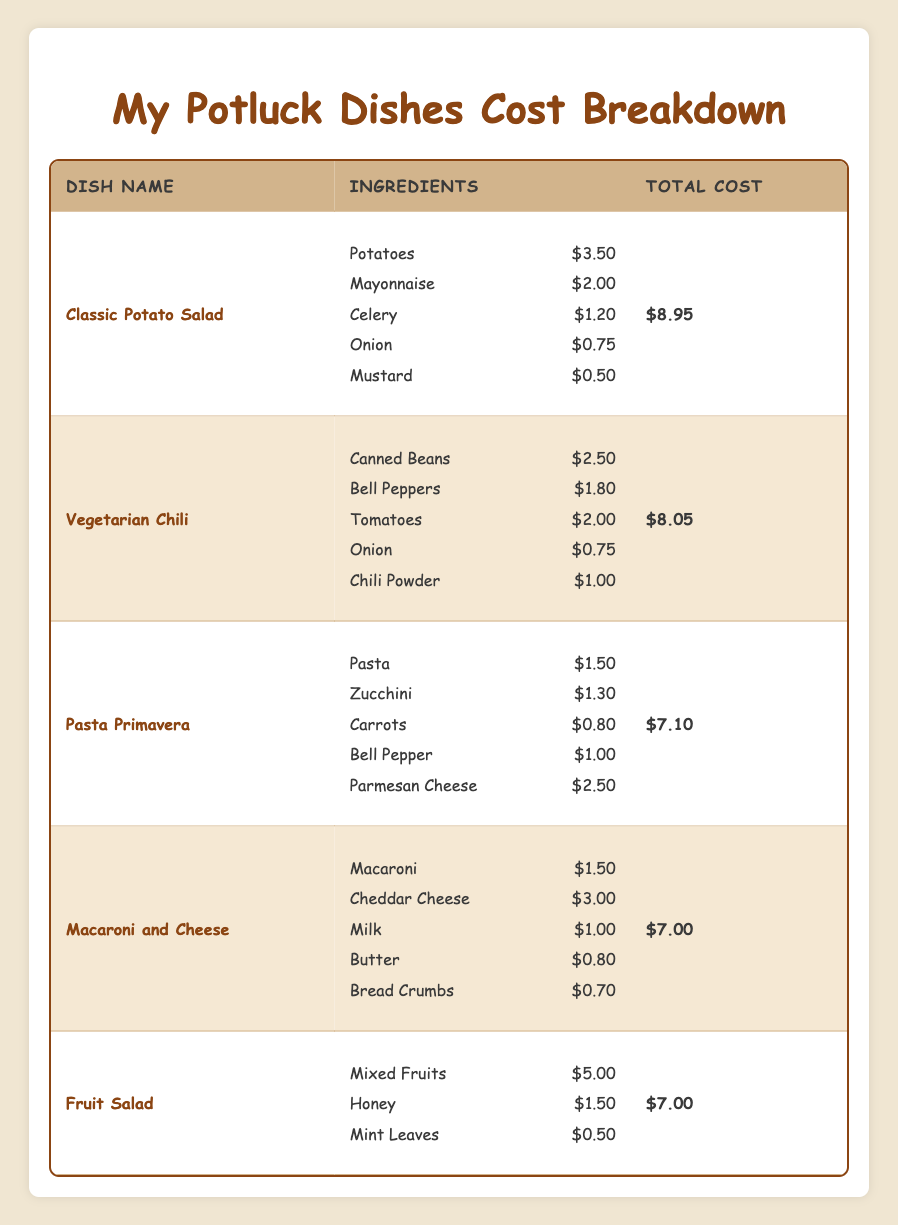What is the total cost of the Classic Potato Salad? The total cost for the Classic Potato Salad is listed directly in the table as $8.95.
Answer: $8.95 Which ingredient in the Vegetarian Chili costs the most? Looking at the ingredient list for Vegetarian Chili, the highest cost is for Tomatoes at $2.00.
Answer: Tomatoes How much does the combined cost of all ingredients in Pasta Primavera amount to? The summation of all ingredients in Pasta Primavera is calculated as follows: $1.50 (Pasta) + $1.30 (Zucchini) + $0.80 (Carrots) + $1.00 (Bell Pepper) + $2.50 (Parmesan Cheese) = $7.10
Answer: $7.10 Is the total cost of Macaroni and Cheese less than that of Vegetarian Chili? The total cost of Macaroni and Cheese is $7.00, and Vegetarian Chili is $8.05. Since $7.00 is less than $8.05, the statement is true.
Answer: Yes How much cheaper is the Classic Potato Salad compared to the Vegetarian Chili? The difference in cost between Classic Potato Salad ($8.95) and Vegetarian Chili ($8.05) is calculated as $8.95 - $8.05 = $0.90.
Answer: $0.90 What is the average cost of ingredients in Fruit Salad? The Fruit Salad has 3 ingredients: Mixed Fruits ($5.00), Honey ($1.50), and Mint Leaves ($0.50). To find the average, sum the costs ($5.00 + $1.50 + $0.50 = $7.00) and divide by the number of ingredients (3): $7.00 / 3 = $2.33.
Answer: $2.33 Which dish has the lowest total cost? By comparing the total costs of all dishes, Macaroni and Cheese and Fruit Salad both have a total cost of $7.00, which is the lowest total cost among the dishes.
Answer: Macaroni and Cheese, Fruit Salad If I wanted to make both Pasta Primavera and Macaroni and Cheese together, what would be the total cost? To find the combined total cost of both dishes, add their total costs: Pasta Primavera ($7.10) + Macaroni and Cheese ($7.00) = $14.10.
Answer: $14.10 Which ingredient in Classic Potato Salad has the lowest cost? Reviewing the ingredient list for Classic Potato Salad, the ingredient with the lowest cost is Mustard at $0.50.
Answer: Mustard What is the total cost of the ingredients in each dish combined? The total costs for all dishes are: Classic Potato Salad ($8.95) + Vegetarian Chili ($8.05) + Pasta Primavera ($7.10) + Macaroni and Cheese ($7.00) + Fruit Salad ($7.00) = $38.10. Therefore, the total cost of all dishes combined is $38.10.
Answer: $38.10 